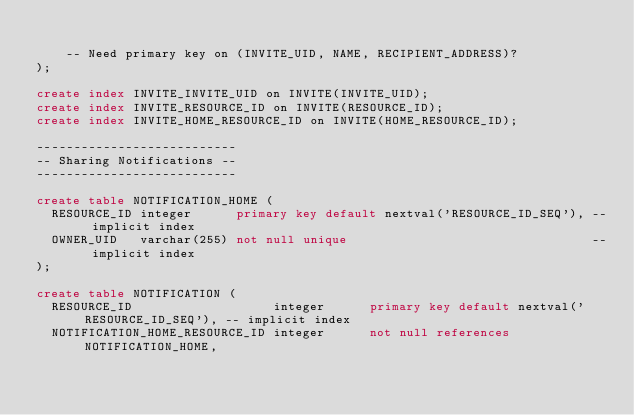Convert code to text. <code><loc_0><loc_0><loc_500><loc_500><_SQL_>
    -- Need primary key on (INVITE_UID, NAME, RECIPIENT_ADDRESS)?
);

create index INVITE_INVITE_UID on INVITE(INVITE_UID);
create index INVITE_RESOURCE_ID on INVITE(RESOURCE_ID);
create index INVITE_HOME_RESOURCE_ID on INVITE(HOME_RESOURCE_ID);

---------------------------
-- Sharing Notifications --
---------------------------

create table NOTIFICATION_HOME (
  RESOURCE_ID integer      primary key default nextval('RESOURCE_ID_SEQ'), -- implicit index
  OWNER_UID   varchar(255) not null unique                                 -- implicit index
);

create table NOTIFICATION (
  RESOURCE_ID                   integer      primary key default nextval('RESOURCE_ID_SEQ'), -- implicit index
  NOTIFICATION_HOME_RESOURCE_ID integer      not null references NOTIFICATION_HOME,</code> 